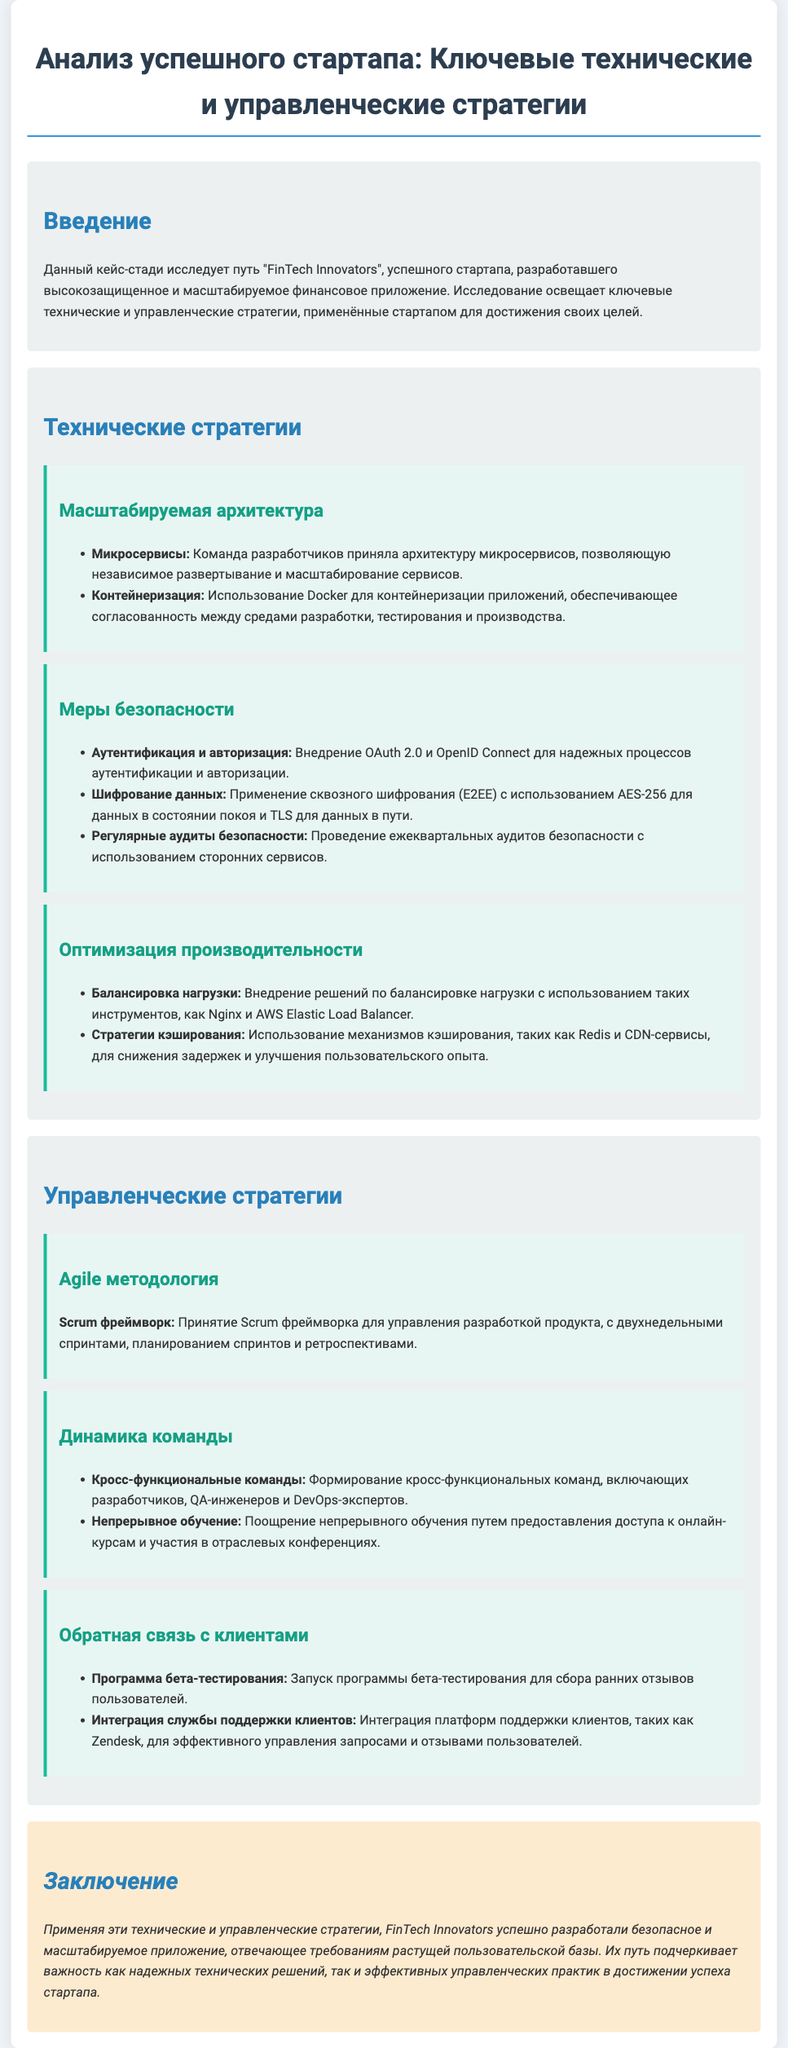Какой стартап рассматривается в кейс-стадии? В документе упоминается стартап "FinTech Innovators", который является объектом исследования.
Answer: FinTech Innovators Какую архитектуру приняла команда разработчиков? Документ указывает на принятие архитектуры микросервисов, что является значением для масштабируемости.
Answer: Микросервисы Какой метод для аутентификации и авторизации был внедрён? Согласно документу, для надежных процессов аутентификации и авторизации использован OAuth 2.0 и OpenID Connect.
Answer: OAuth 2.0 и OpenID Connect Какую стратегию оптимизации производительности применили? В документе указано, что команда внедрила балансировку нагрузки для оптимизации производительности.
Answer: Балансировка нагрузки Какой фреймворк был принят для управления разработкой? В разделе о управленческих стратегиях указано, что используется Scrum фреймворк для управления разработкой продукта.
Answer: Scrum фреймворк Что команда сделала для сбора ранних отзывов пользователей? Запущена программа бета-тестирования для сбора пользователей в проекте, как указано в документе.
Answer: Программа бета-тестирования Какой подход используется для команды? Документ подчеркивает формирование кросс-функциональных команд как важный подход для работы стартапа.
Answer: Кросс-функциональные команды Что является основной мерой безопасности, указанной в документе? Согласно документу, основная мера безопасности - это шифрование данных с использованием AES-256.
Answer: Шифрование данных с использованием AES-256 